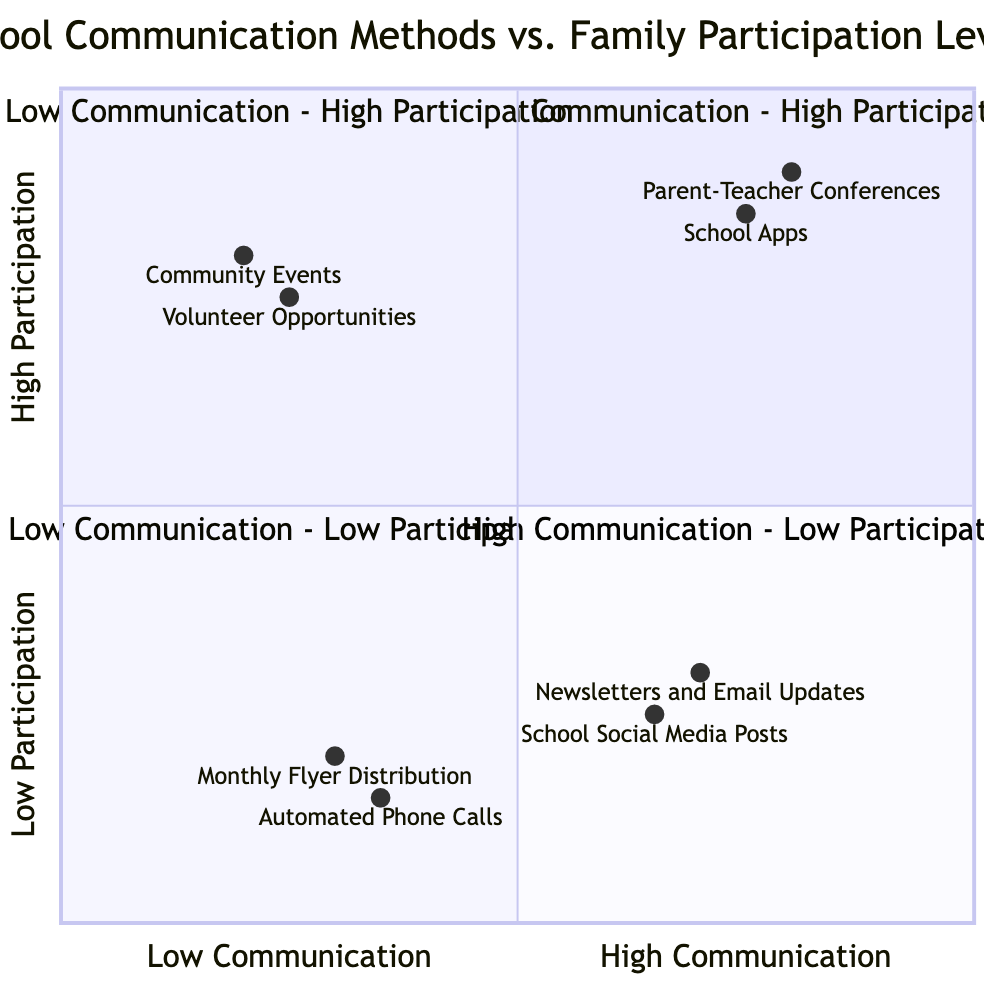What communication method has the highest family participation level? The highest family participation level appears in the "High Communication - High Participation" quadrant. Among the listed methods, "Parent-Teacher Conferences" and "School Apps" have very high participation levels, but "Parent-Teacher Conferences" has a direct positive engagement which indicates a higher level of participation compared to the other methods.
Answer: Parent-Teacher Conferences Which quadrant contains community events? "Community Events" is located in the "Low Communication - High Participation" quadrant. This is determined by the low communication score and the high participation score indicated in its coordinates within the quadrant chart.
Answer: Low Communication - High Participation How many communication methods are in the "Low Communication - Low Participation" quadrant? In the "Low Communication - Low Participation" quadrant, there are two communication methods listed: "Monthly Flyer Distribution" and "Automated Phone Calls." The count of methods indicates the quantity in this specific quadrant.
Answer: 2 What is the level of family participation for newsletters and email updates? This communication method is located in the "High Communication - Low Participation" quadrant based on its coordinates, and it shows a family participation level categorized as "Read-Only Involvement," indicating a limited interaction.
Answer: Read-Only Involvement Which communication method has the lowest participation level? The method with the lowest participation level can be found in the "Low Communication - Low Participation" quadrant. Both "Monthly Flyer Distribution" and "Automated Phone Calls" are low, but "Automated Phone Calls" has a slightly lower participation categorization, indicating minimal engagement.
Answer: Automated Phone Calls What is the relationship between school apps and family participation? "School Apps" are placed in the "High Communication - High Participation" quadrant, which indicates that this method enables frequent interactive feedback from families, showing a strong relationship of engagement and communication.
Answer: Frequent Interactive Feedback Which quadrant shows hands-on support from families? "Hands-On Support" is indicated for "Volunteer Opportunities," which is located in the "Low Communication - High Participation" quadrant. This classification implies that while communication may not be frequent, the level of participation is very active and involved.
Answer: Low Communication - High Participation What is the family participation level for school social media posts? "School Social Media Posts" is located in the "High Communication - Low Participation" quadrant, with its participation level defined as "Occasional Acknowledgement," indicating families engage but not frequently or deeply.
Answer: Occasional Acknowledgement 